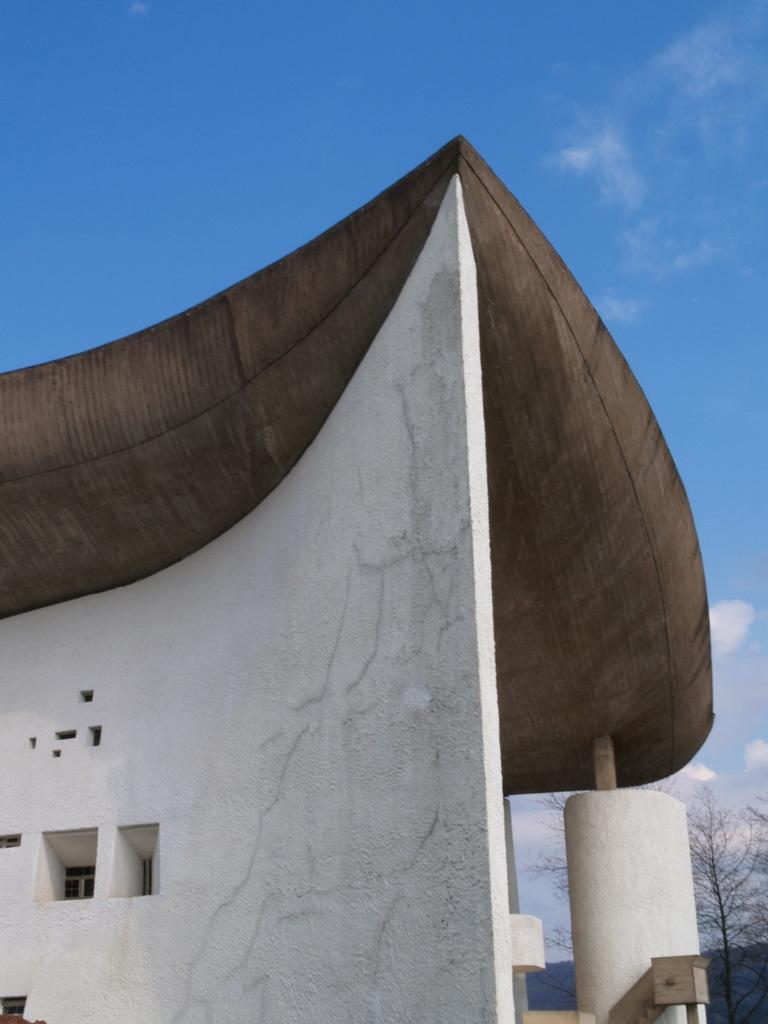What is the main subject of the image? There is a painting in the image. What colors are used in the painting? The painting is in brown and white colors. What can be seen on the right side of the image? There is a dried tree on the right side of the image. What is visible in the background of the image? The sky is visible in the background of the image, and there are clouds present. Where is the key hidden in the image? A: There is no key present in the image. Can you see a toad hopping in the dried tree? There is no toad visible in the image, and the tree is dried, so it would not be able to support a toad. 